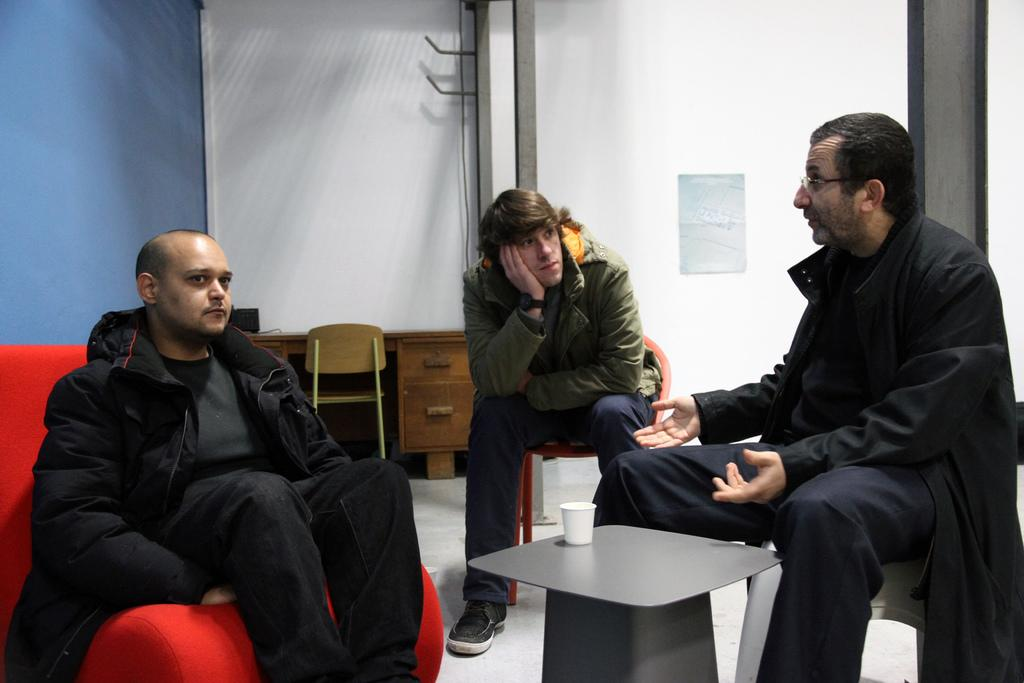How many men are sitting in the foreground of the image? There are three men sitting in the foreground of the image. What is on the table in the foreground? There is a glass on the table in the foreground. What can be seen in the background of the image? There is a wall, a desk, a chair, and the floor visible in the background of the image. What type of skin condition can be seen on the men in the image? There is no indication of any skin condition on the men in the image. What drug is being used by the men in the image? There is no drug use depicted in the image. 